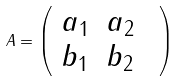Convert formula to latex. <formula><loc_0><loc_0><loc_500><loc_500>A = \left ( \begin{array} { c c c } a _ { 1 } & a _ { 2 } & \\ b _ { 1 } & b _ { 2 } & \end{array} \right )</formula> 